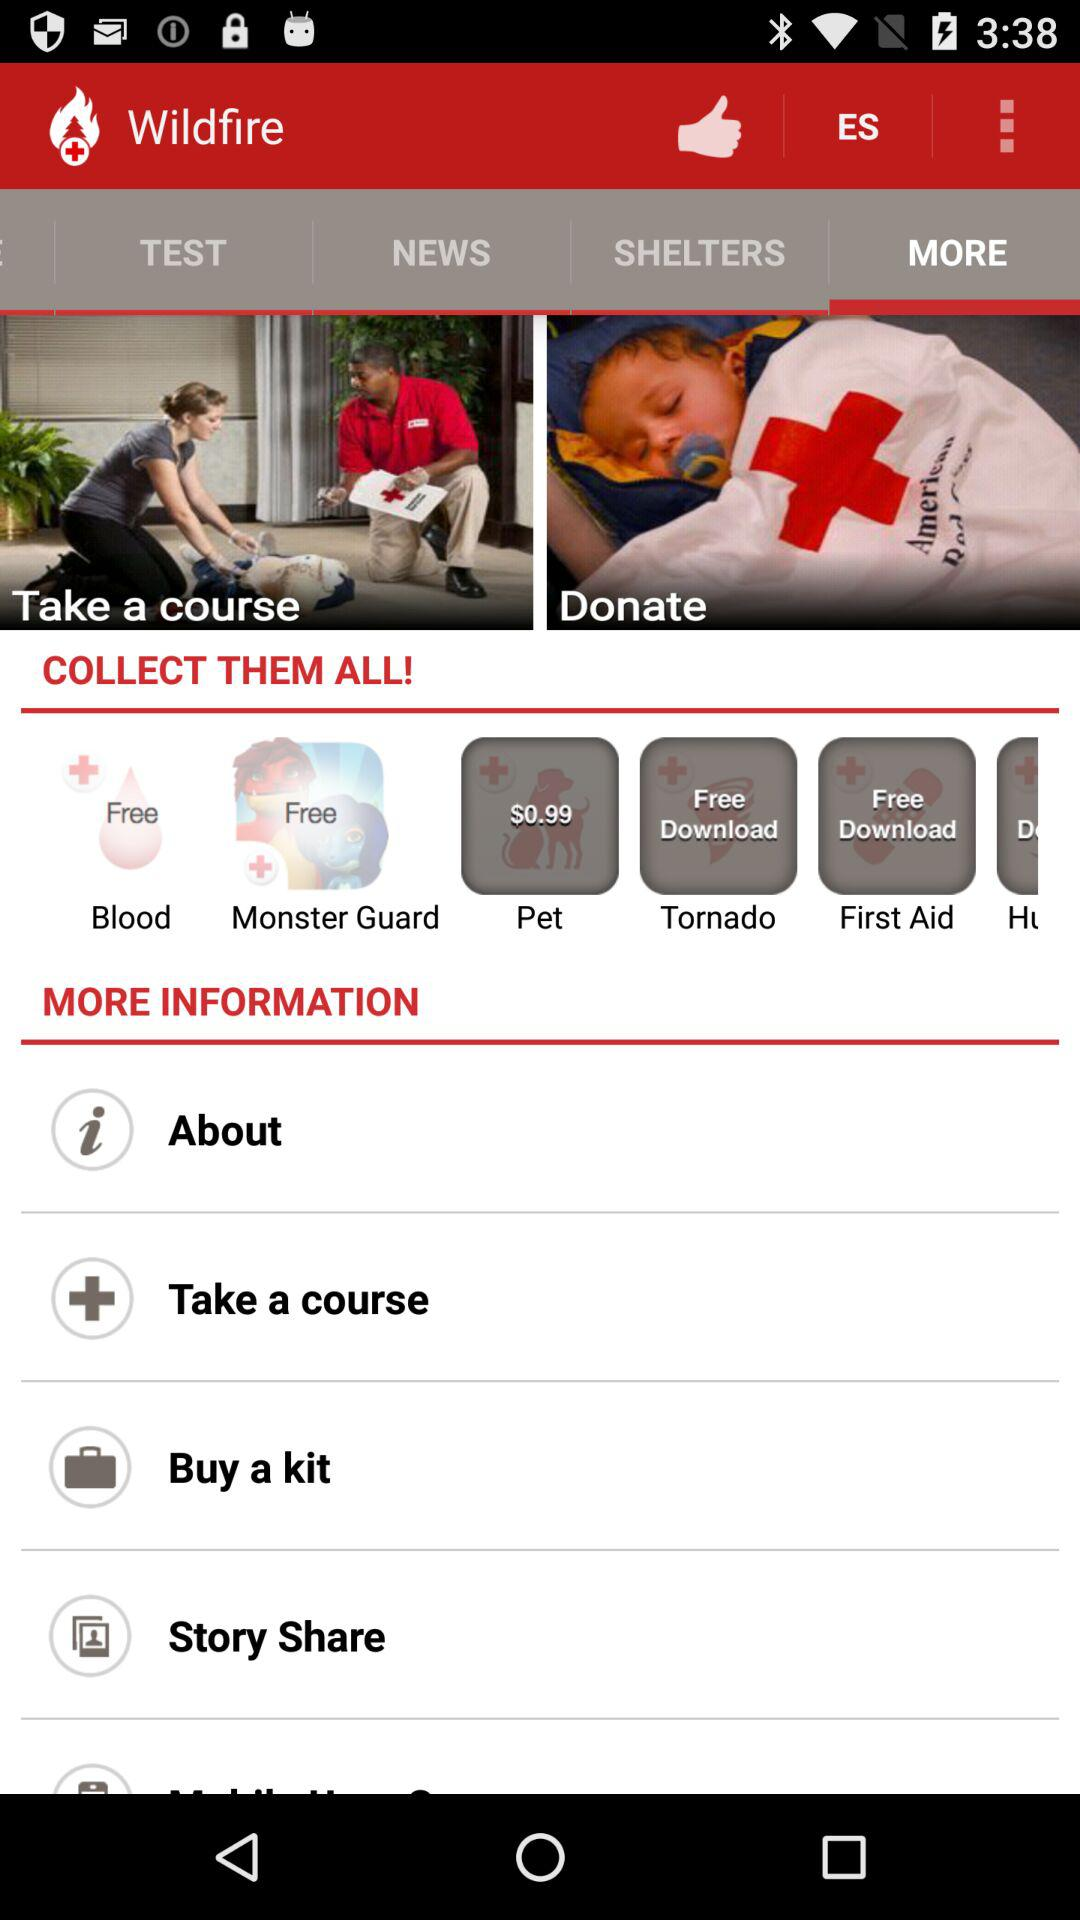How many people gave "Wildfire" a thumbs-up?
When the provided information is insufficient, respond with <no answer>. <no answer> 